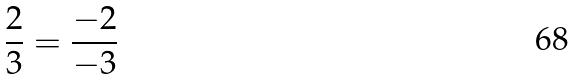<formula> <loc_0><loc_0><loc_500><loc_500>\frac { 2 } { 3 } = \frac { - 2 } { - 3 }</formula> 